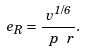<formula> <loc_0><loc_0><loc_500><loc_500>\ e _ { R } = \frac { v ^ { 1 / 6 } } { \ p \ r } .</formula> 